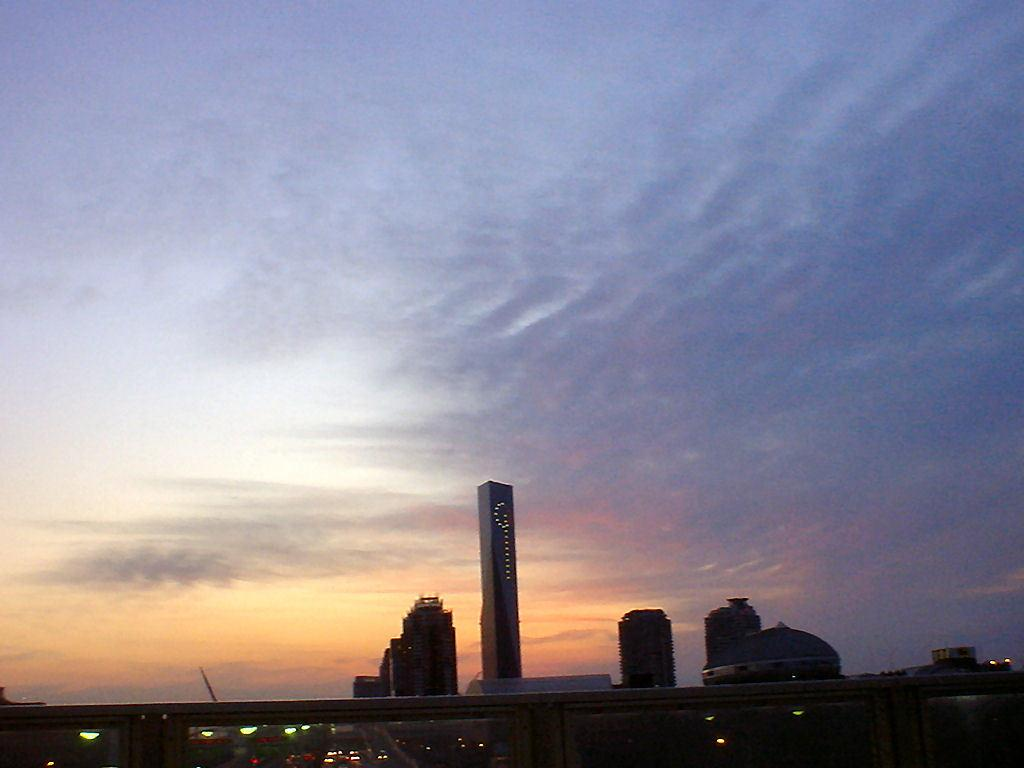What type of structures are present in the image? There is a group of buildings in the image. Are there any visible sources of illumination in the image? Yes, there are lights visible in the image. How would you describe the sky in the background of the image? The sky in the background of the image is cloudy. How many cherries are hanging from the tree in the image? There is no tree or cherries present in the image. What type of learning is taking place in the image? There is no learning activity depicted in the image; it features a group of buildings, lights, and a cloudy sky. 